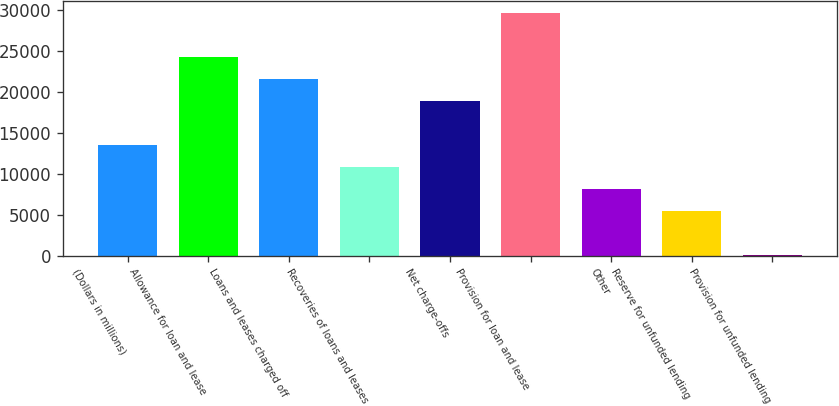Convert chart to OTSL. <chart><loc_0><loc_0><loc_500><loc_500><bar_chart><fcel>(Dollars in millions)<fcel>Allowance for loan and lease<fcel>Loans and leases charged off<fcel>Recoveries of loans and leases<fcel>Net charge-offs<fcel>Provision for loan and lease<fcel>Other<fcel>Reserve for unfunded lending<fcel>Provision for unfunded lending<nl><fcel>13509.5<fcel>24239.5<fcel>21557<fcel>10827<fcel>18874.5<fcel>29604.5<fcel>8144.5<fcel>5462<fcel>97<nl></chart> 